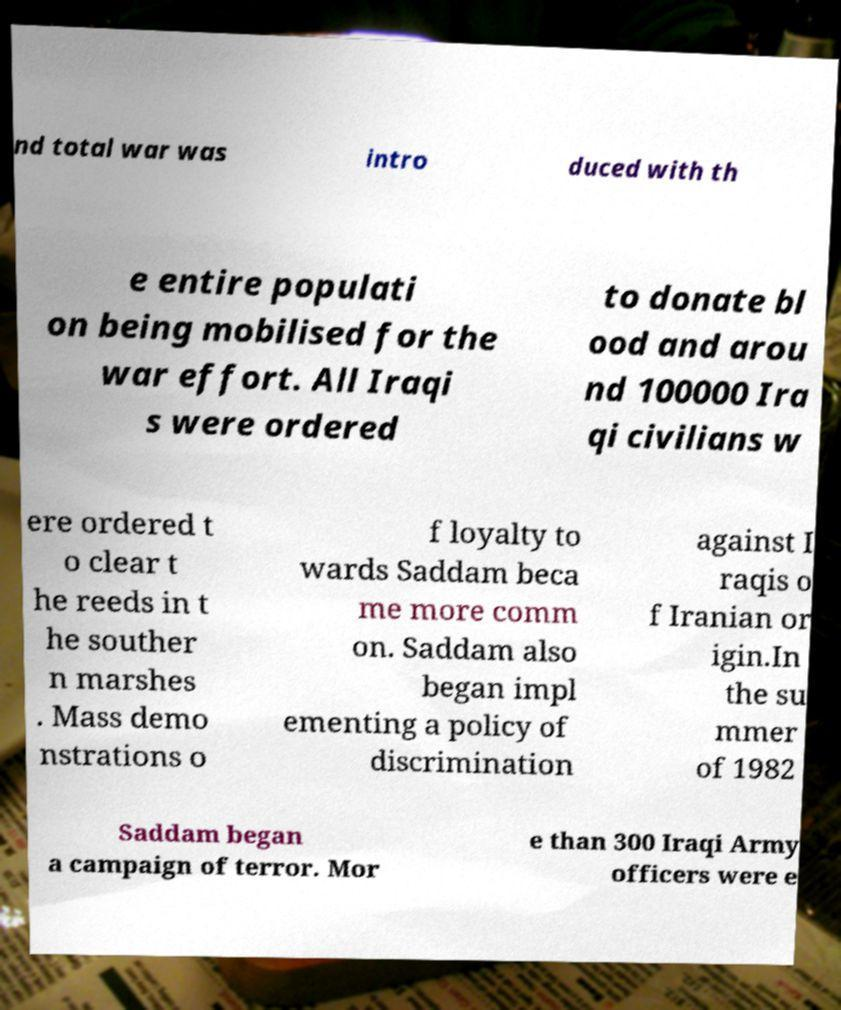Can you accurately transcribe the text from the provided image for me? nd total war was intro duced with th e entire populati on being mobilised for the war effort. All Iraqi s were ordered to donate bl ood and arou nd 100000 Ira qi civilians w ere ordered t o clear t he reeds in t he souther n marshes . Mass demo nstrations o f loyalty to wards Saddam beca me more comm on. Saddam also began impl ementing a policy of discrimination against I raqis o f Iranian or igin.In the su mmer of 1982 Saddam began a campaign of terror. Mor e than 300 Iraqi Army officers were e 